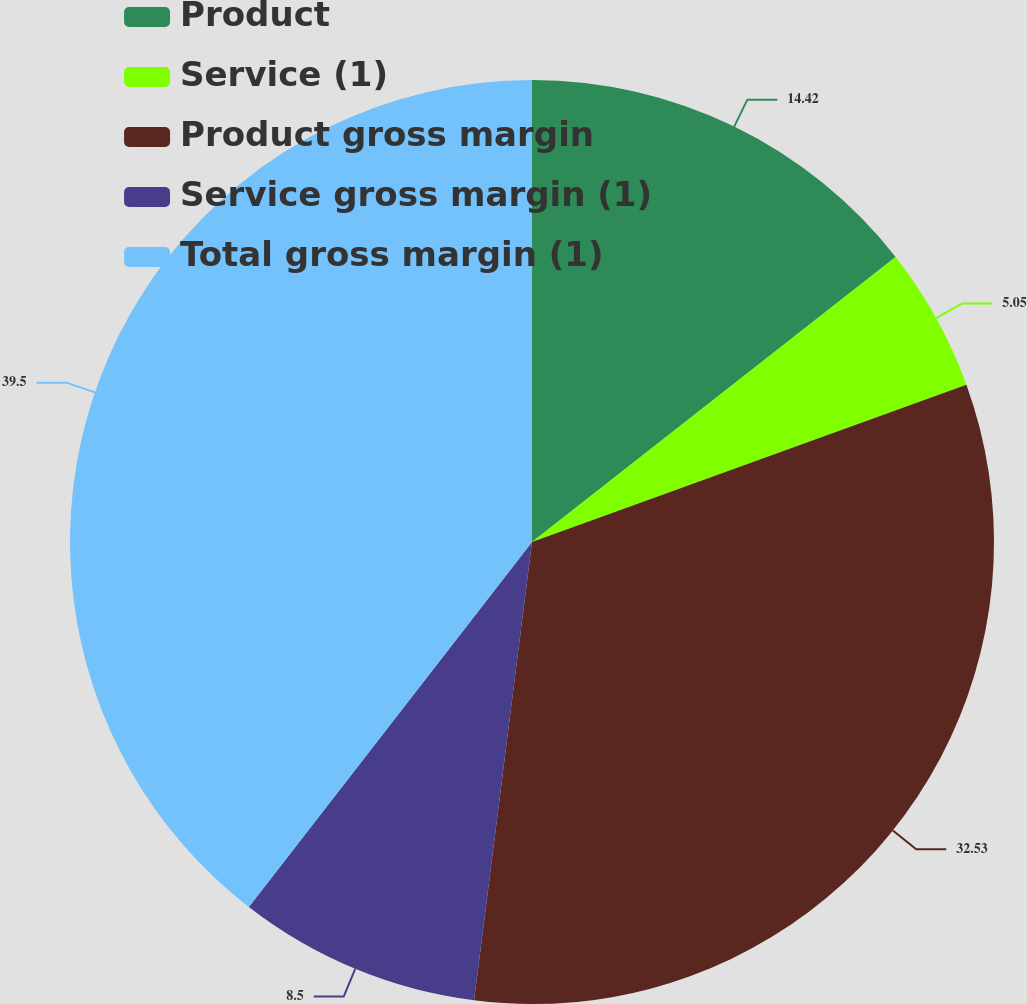Convert chart. <chart><loc_0><loc_0><loc_500><loc_500><pie_chart><fcel>Product<fcel>Service (1)<fcel>Product gross margin<fcel>Service gross margin (1)<fcel>Total gross margin (1)<nl><fcel>14.42%<fcel>5.05%<fcel>32.53%<fcel>8.5%<fcel>39.5%<nl></chart> 